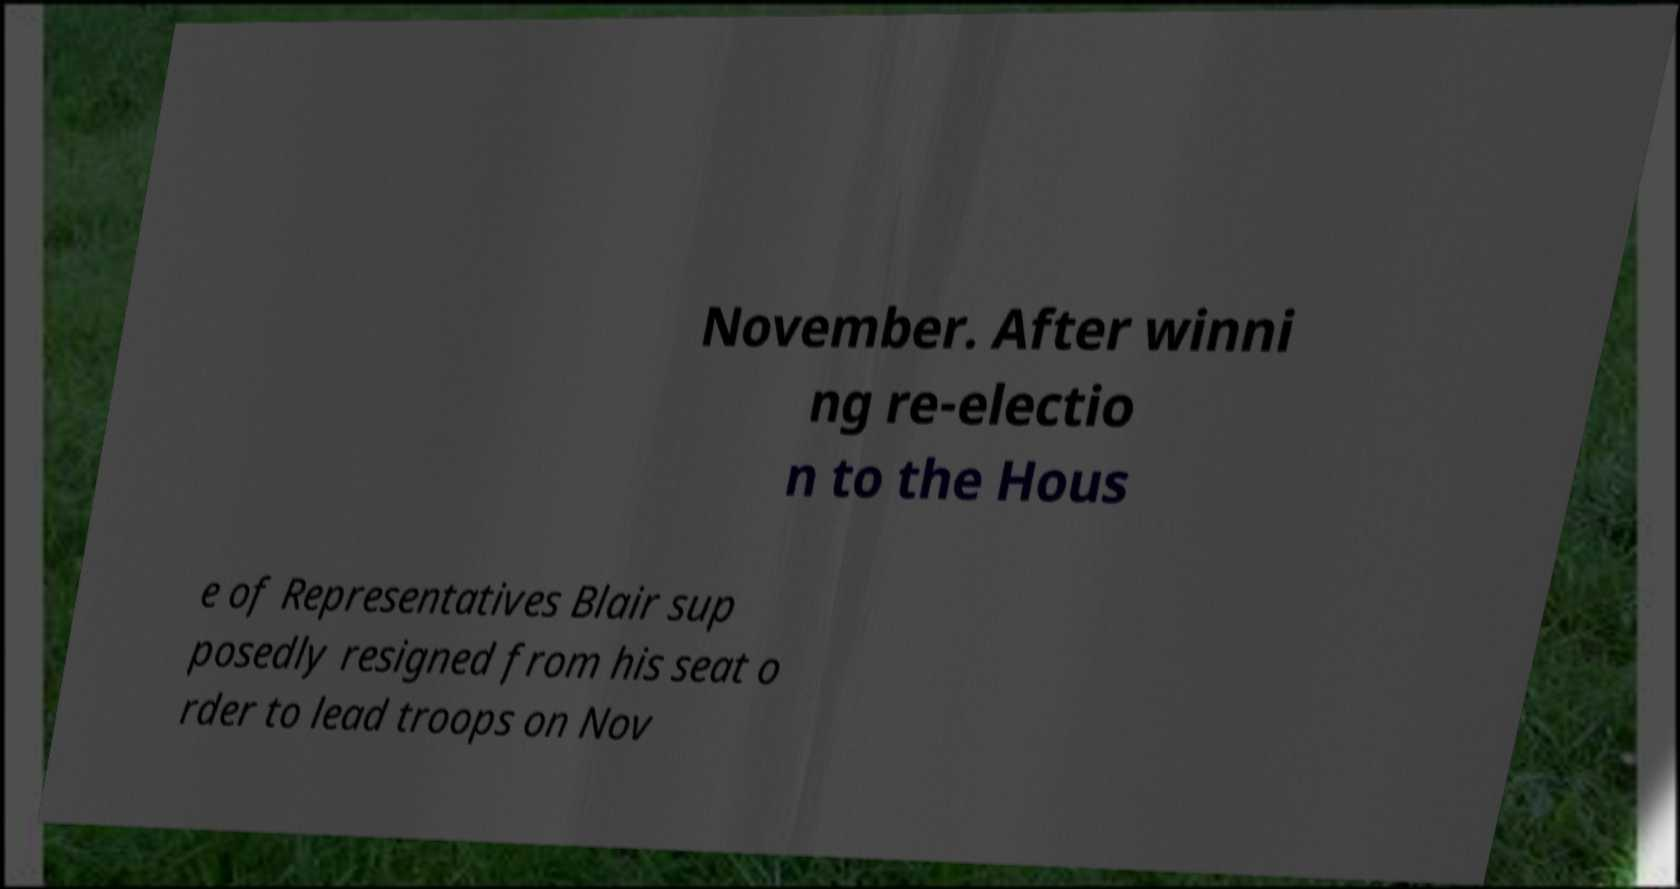Can you read and provide the text displayed in the image?This photo seems to have some interesting text. Can you extract and type it out for me? November. After winni ng re-electio n to the Hous e of Representatives Blair sup posedly resigned from his seat o rder to lead troops on Nov 